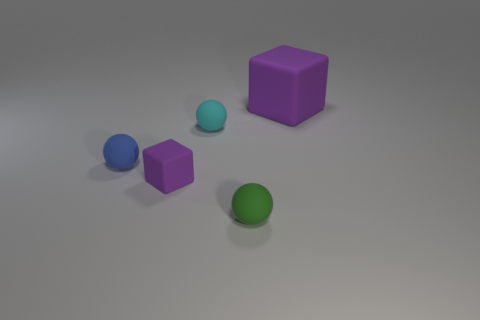Add 2 large red rubber cylinders. How many objects exist? 7 Subtract all cubes. How many objects are left? 3 Add 3 small green matte objects. How many small green matte objects are left? 4 Add 4 blue objects. How many blue objects exist? 5 Subtract 0 blue cylinders. How many objects are left? 5 Subtract all cubes. Subtract all small cubes. How many objects are left? 2 